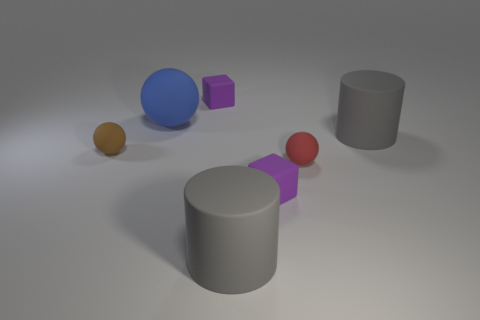Subtract all gray blocks. Subtract all green balls. How many blocks are left? 2 Add 2 tiny brown rubber balls. How many objects exist? 9 Subtract all blocks. How many objects are left? 5 Subtract all large cyan metal spheres. Subtract all large blue matte spheres. How many objects are left? 6 Add 4 tiny brown spheres. How many tiny brown spheres are left? 5 Add 4 large brown cylinders. How many large brown cylinders exist? 4 Subtract 1 brown balls. How many objects are left? 6 